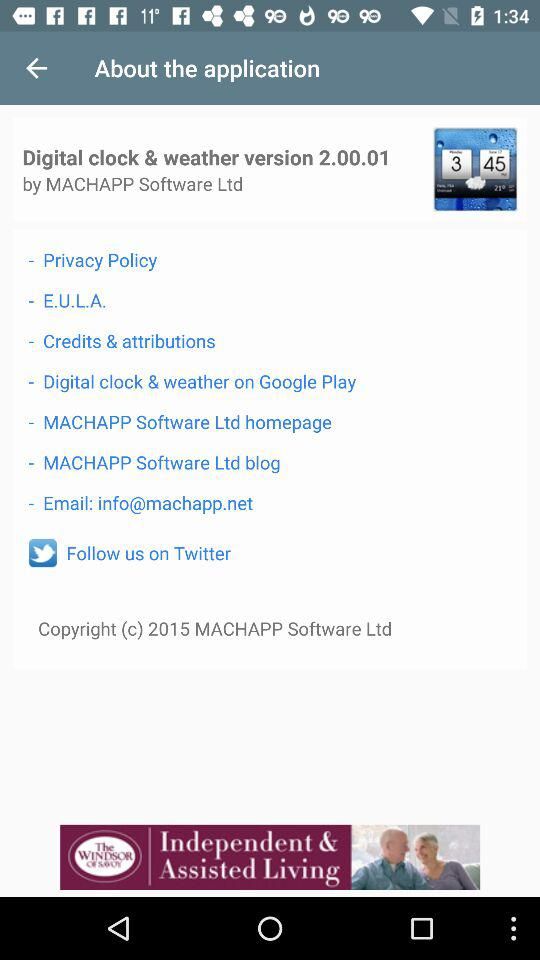What is the version of the "Digital clock & weather" application? The version is 2.00.01. 